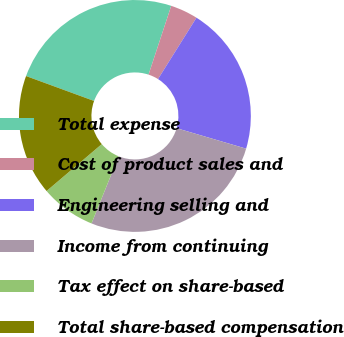<chart> <loc_0><loc_0><loc_500><loc_500><pie_chart><fcel>Total expense<fcel>Cost of product sales and<fcel>Engineering selling and<fcel>Income from continuing<fcel>Tax effect on share-based<fcel>Total share-based compensation<nl><fcel>24.48%<fcel>3.84%<fcel>20.64%<fcel>26.55%<fcel>7.68%<fcel>16.8%<nl></chart> 